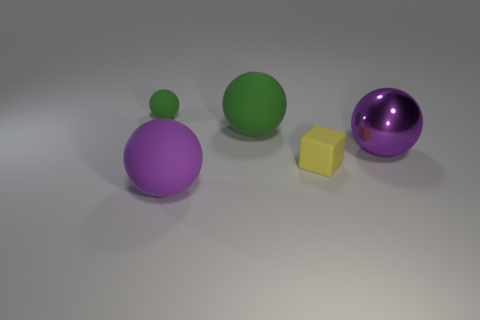Is the purple object that is behind the small yellow rubber object made of the same material as the large green object?
Offer a very short reply. No. What number of other things are the same size as the yellow block?
Keep it short and to the point. 1. What number of large objects are purple metallic spheres or green objects?
Make the answer very short. 2. Does the tiny matte sphere have the same color as the metal ball?
Offer a terse response. No. Are there more tiny rubber blocks that are in front of the tiny yellow object than tiny cubes that are behind the tiny ball?
Keep it short and to the point. No. Is the color of the tiny object to the right of the tiny matte sphere the same as the metallic thing?
Offer a very short reply. No. Are there any other things of the same color as the shiny sphere?
Provide a short and direct response. Yes. Are there more tiny yellow matte objects left of the small block than matte objects?
Your answer should be compact. No. Does the yellow object have the same size as the purple metal thing?
Your response must be concise. No. What is the material of the other green object that is the same shape as the small green rubber thing?
Keep it short and to the point. Rubber. 